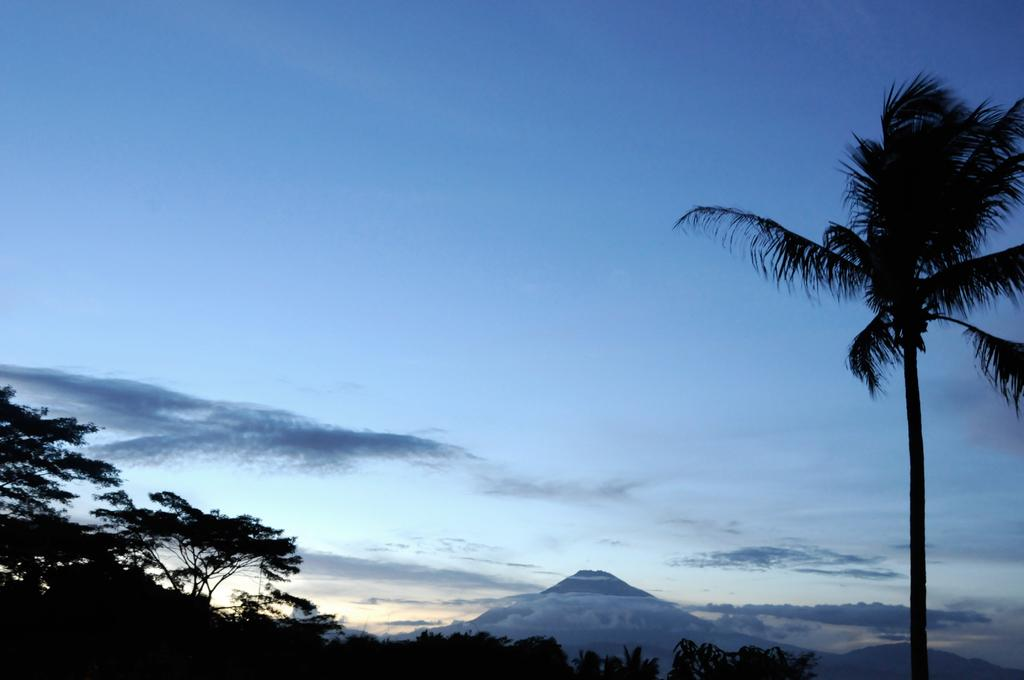What is visible in the center of the image? The sky, clouds, trees, and hills are visible in the center of the image. Can you describe the clouds in the image? The clouds are present in the center of the image. What type of natural landscape is depicted in the image? The image features a combination of sky, clouds, trees, and hills. What type of dirt can be seen falling from the sky in the image? There is no dirt present in the image, and therefore no such activity can be observed. 